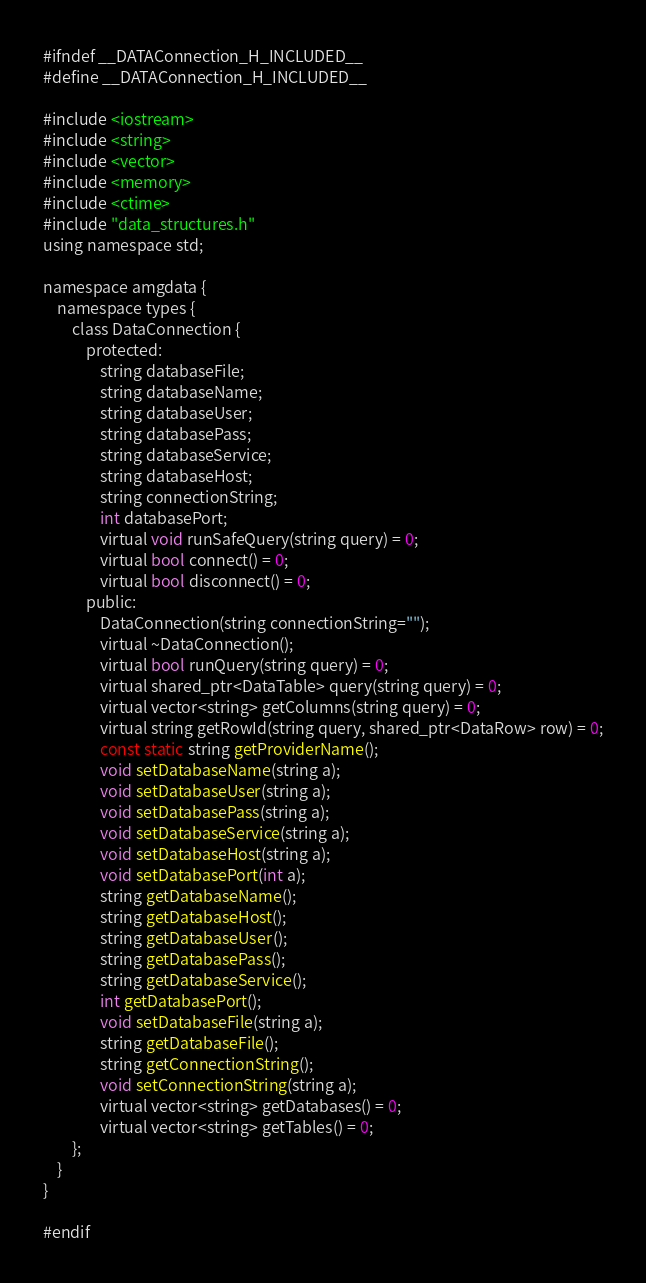Convert code to text. <code><loc_0><loc_0><loc_500><loc_500><_C_>#ifndef __DATAConnection_H_INCLUDED__
#define __DATAConnection_H_INCLUDED__

#include <iostream>
#include <string>
#include <vector>
#include <memory>
#include <ctime>
#include "data_structures.h"
using namespace std;

namespace amgdata {
    namespace types {
        class DataConnection {
            protected:
                string databaseFile;
                string databaseName;
                string databaseUser;
                string databasePass;
                string databaseService;
                string databaseHost;
                string connectionString;
                int databasePort;
                virtual void runSafeQuery(string query) = 0;
                virtual bool connect() = 0;
                virtual bool disconnect() = 0;
            public:
                DataConnection(string connectionString="");
                virtual ~DataConnection();
                virtual bool runQuery(string query) = 0;
                virtual shared_ptr<DataTable> query(string query) = 0;
                virtual vector<string> getColumns(string query) = 0;
                virtual string getRowId(string query, shared_ptr<DataRow> row) = 0;
                const static string getProviderName();
                void setDatabaseName(string a);
                void setDatabaseUser(string a);
                void setDatabasePass(string a);
                void setDatabaseService(string a);
                void setDatabaseHost(string a);
                void setDatabasePort(int a);
                string getDatabaseName();
                string getDatabaseHost();
                string getDatabaseUser();
                string getDatabasePass();
                string getDatabaseService();
                int getDatabasePort();
                void setDatabaseFile(string a);
                string getDatabaseFile();
                string getConnectionString();
                void setConnectionString(string a);
                virtual vector<string> getDatabases() = 0;
                virtual vector<string> getTables() = 0;
        };
    }
}

#endif
</code> 